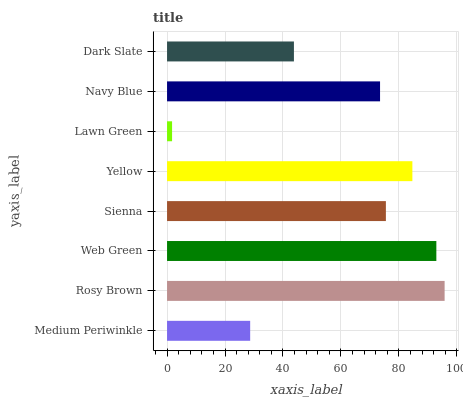Is Lawn Green the minimum?
Answer yes or no. Yes. Is Rosy Brown the maximum?
Answer yes or no. Yes. Is Web Green the minimum?
Answer yes or no. No. Is Web Green the maximum?
Answer yes or no. No. Is Rosy Brown greater than Web Green?
Answer yes or no. Yes. Is Web Green less than Rosy Brown?
Answer yes or no. Yes. Is Web Green greater than Rosy Brown?
Answer yes or no. No. Is Rosy Brown less than Web Green?
Answer yes or no. No. Is Sienna the high median?
Answer yes or no. Yes. Is Navy Blue the low median?
Answer yes or no. Yes. Is Dark Slate the high median?
Answer yes or no. No. Is Sienna the low median?
Answer yes or no. No. 